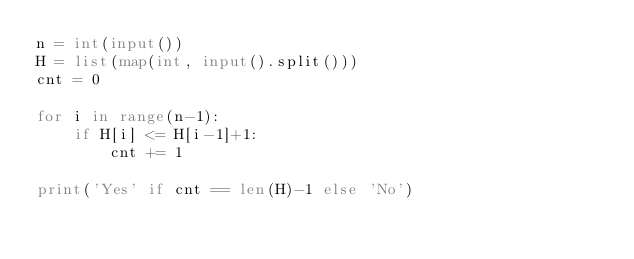<code> <loc_0><loc_0><loc_500><loc_500><_Python_>n = int(input())
H = list(map(int, input().split()))
cnt = 0

for i in range(n-1):
    if H[i] <= H[i-1]+1:
        cnt += 1

print('Yes' if cnt == len(H)-1 else 'No')
</code> 